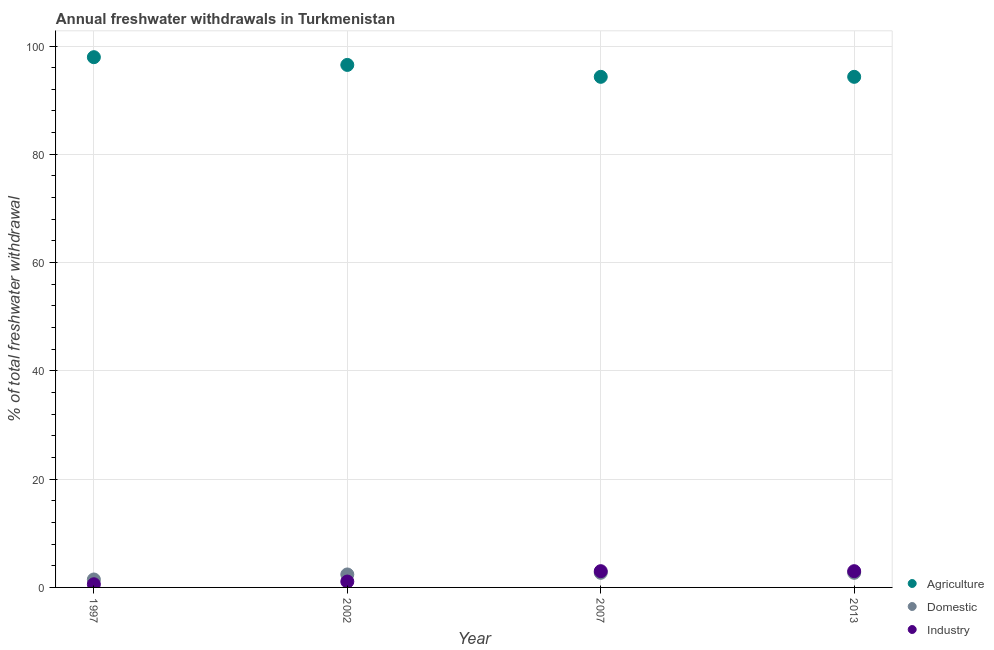How many different coloured dotlines are there?
Your response must be concise. 3. What is the percentage of freshwater withdrawal for domestic purposes in 2002?
Offer a terse response. 2.4. Across all years, what is the maximum percentage of freshwater withdrawal for industry?
Provide a short and direct response. 3. Across all years, what is the minimum percentage of freshwater withdrawal for domestic purposes?
Provide a succinct answer. 1.47. In which year was the percentage of freshwater withdrawal for industry maximum?
Make the answer very short. 2007. What is the total percentage of freshwater withdrawal for agriculture in the graph?
Give a very brief answer. 383.07. What is the difference between the percentage of freshwater withdrawal for industry in 1997 and that in 2007?
Your answer should be very brief. -2.42. What is the difference between the percentage of freshwater withdrawal for domestic purposes in 1997 and the percentage of freshwater withdrawal for agriculture in 2002?
Your answer should be compact. -95.04. What is the average percentage of freshwater withdrawal for domestic purposes per year?
Your response must be concise. 2.32. In the year 2002, what is the difference between the percentage of freshwater withdrawal for agriculture and percentage of freshwater withdrawal for industry?
Keep it short and to the point. 95.43. What is the ratio of the percentage of freshwater withdrawal for domestic purposes in 1997 to that in 2013?
Your answer should be very brief. 0.54. Is the difference between the percentage of freshwater withdrawal for agriculture in 2002 and 2007 greater than the difference between the percentage of freshwater withdrawal for industry in 2002 and 2007?
Your answer should be very brief. Yes. What is the difference between the highest and the second highest percentage of freshwater withdrawal for industry?
Offer a terse response. 0. What is the difference between the highest and the lowest percentage of freshwater withdrawal for domestic purposes?
Ensure brevity in your answer.  1.23. In how many years, is the percentage of freshwater withdrawal for domestic purposes greater than the average percentage of freshwater withdrawal for domestic purposes taken over all years?
Provide a succinct answer. 3. Is the sum of the percentage of freshwater withdrawal for domestic purposes in 2002 and 2013 greater than the maximum percentage of freshwater withdrawal for industry across all years?
Keep it short and to the point. Yes. Is it the case that in every year, the sum of the percentage of freshwater withdrawal for agriculture and percentage of freshwater withdrawal for domestic purposes is greater than the percentage of freshwater withdrawal for industry?
Offer a very short reply. Yes. Is the percentage of freshwater withdrawal for industry strictly greater than the percentage of freshwater withdrawal for agriculture over the years?
Your response must be concise. No. Is the percentage of freshwater withdrawal for industry strictly less than the percentage of freshwater withdrawal for domestic purposes over the years?
Provide a short and direct response. No. How many dotlines are there?
Provide a short and direct response. 3. How many years are there in the graph?
Provide a succinct answer. 4. What is the difference between two consecutive major ticks on the Y-axis?
Give a very brief answer. 20. Are the values on the major ticks of Y-axis written in scientific E-notation?
Offer a terse response. No. Does the graph contain any zero values?
Give a very brief answer. No. Does the graph contain grids?
Your response must be concise. Yes. How are the legend labels stacked?
Make the answer very short. Vertical. What is the title of the graph?
Your answer should be compact. Annual freshwater withdrawals in Turkmenistan. What is the label or title of the X-axis?
Provide a succinct answer. Year. What is the label or title of the Y-axis?
Give a very brief answer. % of total freshwater withdrawal. What is the % of total freshwater withdrawal of Agriculture in 1997?
Keep it short and to the point. 97.94. What is the % of total freshwater withdrawal of Domestic in 1997?
Provide a succinct answer. 1.47. What is the % of total freshwater withdrawal in Industry in 1997?
Offer a terse response. 0.58. What is the % of total freshwater withdrawal in Agriculture in 2002?
Provide a succinct answer. 96.51. What is the % of total freshwater withdrawal in Domestic in 2002?
Your response must be concise. 2.4. What is the % of total freshwater withdrawal of Industry in 2002?
Your response must be concise. 1.08. What is the % of total freshwater withdrawal in Agriculture in 2007?
Provide a succinct answer. 94.31. What is the % of total freshwater withdrawal of Domestic in 2007?
Keep it short and to the point. 2.7. What is the % of total freshwater withdrawal in Industry in 2007?
Offer a very short reply. 3. What is the % of total freshwater withdrawal in Agriculture in 2013?
Your answer should be very brief. 94.31. What is the % of total freshwater withdrawal in Domestic in 2013?
Your answer should be very brief. 2.7. What is the % of total freshwater withdrawal in Industry in 2013?
Make the answer very short. 3. Across all years, what is the maximum % of total freshwater withdrawal in Agriculture?
Offer a terse response. 97.94. Across all years, what is the maximum % of total freshwater withdrawal of Domestic?
Keep it short and to the point. 2.7. Across all years, what is the maximum % of total freshwater withdrawal of Industry?
Your answer should be compact. 3. Across all years, what is the minimum % of total freshwater withdrawal in Agriculture?
Offer a terse response. 94.31. Across all years, what is the minimum % of total freshwater withdrawal of Domestic?
Give a very brief answer. 1.47. Across all years, what is the minimum % of total freshwater withdrawal of Industry?
Keep it short and to the point. 0.58. What is the total % of total freshwater withdrawal of Agriculture in the graph?
Your answer should be very brief. 383.07. What is the total % of total freshwater withdrawal of Domestic in the graph?
Make the answer very short. 9.27. What is the total % of total freshwater withdrawal in Industry in the graph?
Ensure brevity in your answer.  7.67. What is the difference between the % of total freshwater withdrawal of Agriculture in 1997 and that in 2002?
Give a very brief answer. 1.43. What is the difference between the % of total freshwater withdrawal of Domestic in 1997 and that in 2002?
Make the answer very short. -0.93. What is the difference between the % of total freshwater withdrawal of Industry in 1997 and that in 2002?
Offer a very short reply. -0.5. What is the difference between the % of total freshwater withdrawal of Agriculture in 1997 and that in 2007?
Provide a succinct answer. 3.63. What is the difference between the % of total freshwater withdrawal of Domestic in 1997 and that in 2007?
Offer a very short reply. -1.23. What is the difference between the % of total freshwater withdrawal of Industry in 1997 and that in 2007?
Your answer should be very brief. -2.42. What is the difference between the % of total freshwater withdrawal of Agriculture in 1997 and that in 2013?
Provide a succinct answer. 3.63. What is the difference between the % of total freshwater withdrawal in Domestic in 1997 and that in 2013?
Your answer should be very brief. -1.23. What is the difference between the % of total freshwater withdrawal in Industry in 1997 and that in 2013?
Keep it short and to the point. -2.42. What is the difference between the % of total freshwater withdrawal of Domestic in 2002 and that in 2007?
Offer a very short reply. -0.3. What is the difference between the % of total freshwater withdrawal of Industry in 2002 and that in 2007?
Offer a very short reply. -1.92. What is the difference between the % of total freshwater withdrawal of Domestic in 2002 and that in 2013?
Your response must be concise. -0.3. What is the difference between the % of total freshwater withdrawal in Industry in 2002 and that in 2013?
Your response must be concise. -1.92. What is the difference between the % of total freshwater withdrawal of Agriculture in 2007 and that in 2013?
Make the answer very short. 0. What is the difference between the % of total freshwater withdrawal in Industry in 2007 and that in 2013?
Ensure brevity in your answer.  0. What is the difference between the % of total freshwater withdrawal in Agriculture in 1997 and the % of total freshwater withdrawal in Domestic in 2002?
Make the answer very short. 95.54. What is the difference between the % of total freshwater withdrawal of Agriculture in 1997 and the % of total freshwater withdrawal of Industry in 2002?
Your response must be concise. 96.86. What is the difference between the % of total freshwater withdrawal of Domestic in 1997 and the % of total freshwater withdrawal of Industry in 2002?
Give a very brief answer. 0.38. What is the difference between the % of total freshwater withdrawal in Agriculture in 1997 and the % of total freshwater withdrawal in Domestic in 2007?
Your answer should be compact. 95.24. What is the difference between the % of total freshwater withdrawal in Agriculture in 1997 and the % of total freshwater withdrawal in Industry in 2007?
Ensure brevity in your answer.  94.94. What is the difference between the % of total freshwater withdrawal in Domestic in 1997 and the % of total freshwater withdrawal in Industry in 2007?
Provide a succinct answer. -1.53. What is the difference between the % of total freshwater withdrawal in Agriculture in 1997 and the % of total freshwater withdrawal in Domestic in 2013?
Offer a terse response. 95.24. What is the difference between the % of total freshwater withdrawal of Agriculture in 1997 and the % of total freshwater withdrawal of Industry in 2013?
Offer a terse response. 94.94. What is the difference between the % of total freshwater withdrawal in Domestic in 1997 and the % of total freshwater withdrawal in Industry in 2013?
Keep it short and to the point. -1.53. What is the difference between the % of total freshwater withdrawal in Agriculture in 2002 and the % of total freshwater withdrawal in Domestic in 2007?
Give a very brief answer. 93.81. What is the difference between the % of total freshwater withdrawal of Agriculture in 2002 and the % of total freshwater withdrawal of Industry in 2007?
Offer a terse response. 93.51. What is the difference between the % of total freshwater withdrawal of Domestic in 2002 and the % of total freshwater withdrawal of Industry in 2007?
Provide a short and direct response. -0.6. What is the difference between the % of total freshwater withdrawal in Agriculture in 2002 and the % of total freshwater withdrawal in Domestic in 2013?
Ensure brevity in your answer.  93.81. What is the difference between the % of total freshwater withdrawal of Agriculture in 2002 and the % of total freshwater withdrawal of Industry in 2013?
Your answer should be compact. 93.51. What is the difference between the % of total freshwater withdrawal of Domestic in 2002 and the % of total freshwater withdrawal of Industry in 2013?
Offer a very short reply. -0.6. What is the difference between the % of total freshwater withdrawal of Agriculture in 2007 and the % of total freshwater withdrawal of Domestic in 2013?
Your response must be concise. 91.61. What is the difference between the % of total freshwater withdrawal of Agriculture in 2007 and the % of total freshwater withdrawal of Industry in 2013?
Provide a short and direct response. 91.31. What is the difference between the % of total freshwater withdrawal of Domestic in 2007 and the % of total freshwater withdrawal of Industry in 2013?
Your response must be concise. -0.3. What is the average % of total freshwater withdrawal of Agriculture per year?
Provide a succinct answer. 95.77. What is the average % of total freshwater withdrawal of Domestic per year?
Your answer should be compact. 2.32. What is the average % of total freshwater withdrawal of Industry per year?
Keep it short and to the point. 1.92. In the year 1997, what is the difference between the % of total freshwater withdrawal in Agriculture and % of total freshwater withdrawal in Domestic?
Keep it short and to the point. 96.47. In the year 1997, what is the difference between the % of total freshwater withdrawal in Agriculture and % of total freshwater withdrawal in Industry?
Offer a very short reply. 97.36. In the year 1997, what is the difference between the % of total freshwater withdrawal of Domestic and % of total freshwater withdrawal of Industry?
Make the answer very short. 0.88. In the year 2002, what is the difference between the % of total freshwater withdrawal in Agriculture and % of total freshwater withdrawal in Domestic?
Keep it short and to the point. 94.11. In the year 2002, what is the difference between the % of total freshwater withdrawal in Agriculture and % of total freshwater withdrawal in Industry?
Provide a succinct answer. 95.43. In the year 2002, what is the difference between the % of total freshwater withdrawal in Domestic and % of total freshwater withdrawal in Industry?
Provide a succinct answer. 1.31. In the year 2007, what is the difference between the % of total freshwater withdrawal of Agriculture and % of total freshwater withdrawal of Domestic?
Offer a very short reply. 91.61. In the year 2007, what is the difference between the % of total freshwater withdrawal of Agriculture and % of total freshwater withdrawal of Industry?
Keep it short and to the point. 91.31. In the year 2007, what is the difference between the % of total freshwater withdrawal in Domestic and % of total freshwater withdrawal in Industry?
Ensure brevity in your answer.  -0.3. In the year 2013, what is the difference between the % of total freshwater withdrawal in Agriculture and % of total freshwater withdrawal in Domestic?
Offer a very short reply. 91.61. In the year 2013, what is the difference between the % of total freshwater withdrawal of Agriculture and % of total freshwater withdrawal of Industry?
Your answer should be very brief. 91.31. In the year 2013, what is the difference between the % of total freshwater withdrawal in Domestic and % of total freshwater withdrawal in Industry?
Your answer should be very brief. -0.3. What is the ratio of the % of total freshwater withdrawal in Agriculture in 1997 to that in 2002?
Your answer should be compact. 1.01. What is the ratio of the % of total freshwater withdrawal in Domestic in 1997 to that in 2002?
Your answer should be very brief. 0.61. What is the ratio of the % of total freshwater withdrawal in Industry in 1997 to that in 2002?
Provide a succinct answer. 0.54. What is the ratio of the % of total freshwater withdrawal in Agriculture in 1997 to that in 2007?
Keep it short and to the point. 1.04. What is the ratio of the % of total freshwater withdrawal of Domestic in 1997 to that in 2007?
Offer a very short reply. 0.54. What is the ratio of the % of total freshwater withdrawal of Industry in 1997 to that in 2007?
Give a very brief answer. 0.19. What is the ratio of the % of total freshwater withdrawal in Domestic in 1997 to that in 2013?
Keep it short and to the point. 0.54. What is the ratio of the % of total freshwater withdrawal in Industry in 1997 to that in 2013?
Make the answer very short. 0.19. What is the ratio of the % of total freshwater withdrawal of Agriculture in 2002 to that in 2007?
Make the answer very short. 1.02. What is the ratio of the % of total freshwater withdrawal in Domestic in 2002 to that in 2007?
Provide a succinct answer. 0.89. What is the ratio of the % of total freshwater withdrawal of Industry in 2002 to that in 2007?
Make the answer very short. 0.36. What is the ratio of the % of total freshwater withdrawal in Agriculture in 2002 to that in 2013?
Make the answer very short. 1.02. What is the ratio of the % of total freshwater withdrawal in Domestic in 2002 to that in 2013?
Make the answer very short. 0.89. What is the ratio of the % of total freshwater withdrawal in Industry in 2002 to that in 2013?
Make the answer very short. 0.36. What is the ratio of the % of total freshwater withdrawal in Agriculture in 2007 to that in 2013?
Give a very brief answer. 1. What is the ratio of the % of total freshwater withdrawal of Domestic in 2007 to that in 2013?
Provide a succinct answer. 1. What is the difference between the highest and the second highest % of total freshwater withdrawal in Agriculture?
Make the answer very short. 1.43. What is the difference between the highest and the second highest % of total freshwater withdrawal in Industry?
Ensure brevity in your answer.  0. What is the difference between the highest and the lowest % of total freshwater withdrawal in Agriculture?
Ensure brevity in your answer.  3.63. What is the difference between the highest and the lowest % of total freshwater withdrawal in Domestic?
Offer a very short reply. 1.23. What is the difference between the highest and the lowest % of total freshwater withdrawal in Industry?
Make the answer very short. 2.42. 